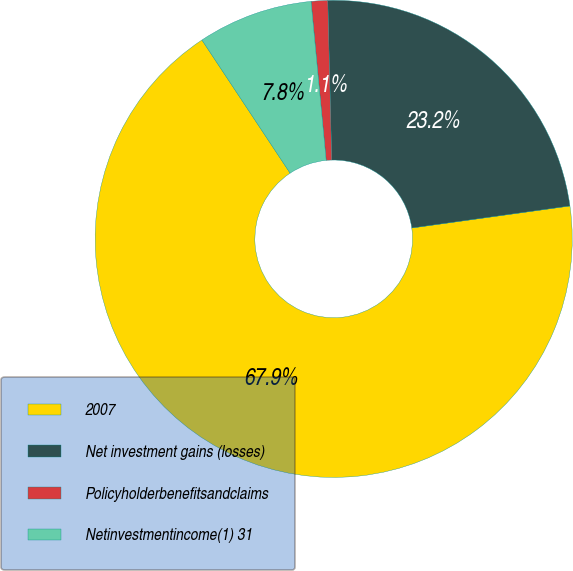<chart> <loc_0><loc_0><loc_500><loc_500><pie_chart><fcel>2007<fcel>Net investment gains (losses)<fcel>Policyholderbenefitsandclaims<fcel>Netinvestmentincome(1) 31<nl><fcel>67.9%<fcel>23.19%<fcel>1.12%<fcel>7.8%<nl></chart> 